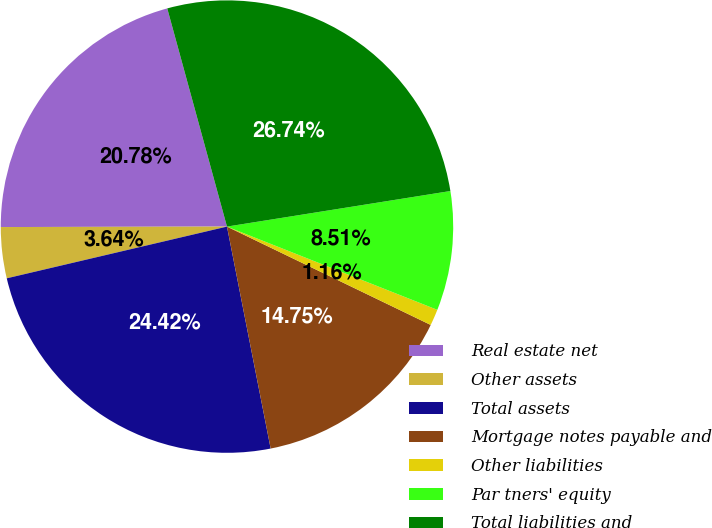Convert chart. <chart><loc_0><loc_0><loc_500><loc_500><pie_chart><fcel>Real estate net<fcel>Other assets<fcel>Total assets<fcel>Mortgage notes payable and<fcel>Other liabilities<fcel>Par tners' equity<fcel>Total liabilities and<nl><fcel>20.78%<fcel>3.64%<fcel>24.42%<fcel>14.75%<fcel>1.16%<fcel>8.51%<fcel>26.74%<nl></chart> 